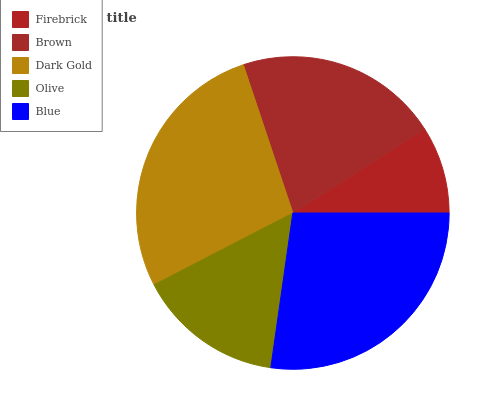Is Firebrick the minimum?
Answer yes or no. Yes. Is Dark Gold the maximum?
Answer yes or no. Yes. Is Brown the minimum?
Answer yes or no. No. Is Brown the maximum?
Answer yes or no. No. Is Brown greater than Firebrick?
Answer yes or no. Yes. Is Firebrick less than Brown?
Answer yes or no. Yes. Is Firebrick greater than Brown?
Answer yes or no. No. Is Brown less than Firebrick?
Answer yes or no. No. Is Brown the high median?
Answer yes or no. Yes. Is Brown the low median?
Answer yes or no. Yes. Is Firebrick the high median?
Answer yes or no. No. Is Olive the low median?
Answer yes or no. No. 